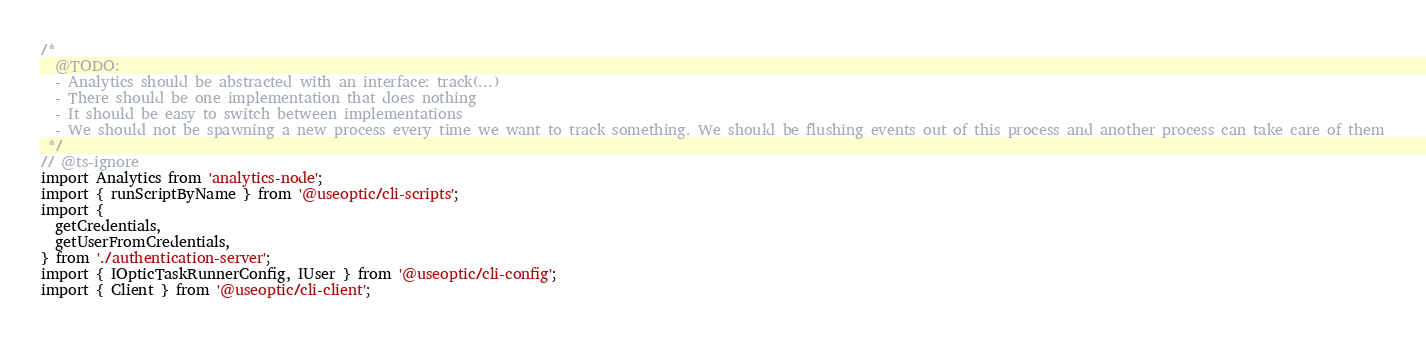Convert code to text. <code><loc_0><loc_0><loc_500><loc_500><_TypeScript_>/*
  @TODO:
  - Analytics should be abstracted with an interface: track(...)
  - There should be one implementation that does nothing
  - It should be easy to switch between implementations
  - We should not be spawning a new process every time we want to track something. We should be flushing events out of this process and another process can take care of them
 */
// @ts-ignore
import Analytics from 'analytics-node';
import { runScriptByName } from '@useoptic/cli-scripts';
import {
  getCredentials,
  getUserFromCredentials,
} from './authentication-server';
import { IOpticTaskRunnerConfig, IUser } from '@useoptic/cli-config';
import { Client } from '@useoptic/cli-client';</code> 